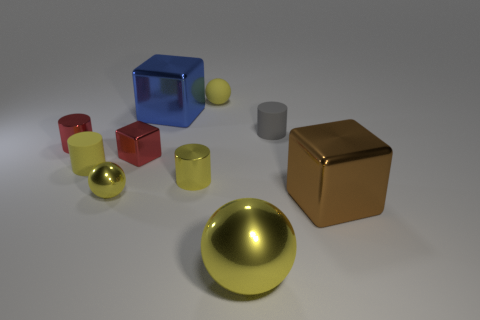What number of things are shiny things in front of the gray cylinder or small balls behind the gray matte cylinder?
Make the answer very short. 7. There is a brown object; what shape is it?
Ensure brevity in your answer.  Cube. How many other objects are there of the same material as the brown block?
Your response must be concise. 6. What size is the rubber thing that is the same shape as the big yellow metal thing?
Give a very brief answer. Small. There is a yellow sphere that is right of the yellow matte thing that is to the right of the big shiny object behind the small gray cylinder; what is its material?
Provide a succinct answer. Metal. Are any green objects visible?
Make the answer very short. No. Does the large ball have the same color as the shiny cube right of the gray object?
Offer a very short reply. No. The big metallic sphere is what color?
Offer a very short reply. Yellow. Is there any other thing that has the same shape as the blue thing?
Your answer should be compact. Yes. There is another big object that is the same shape as the blue object; what is its color?
Provide a short and direct response. Brown. 